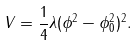<formula> <loc_0><loc_0><loc_500><loc_500>V = \frac { 1 } { 4 } \lambda ( \phi ^ { 2 } - \phi ^ { 2 } _ { 0 } ) ^ { 2 } .</formula> 